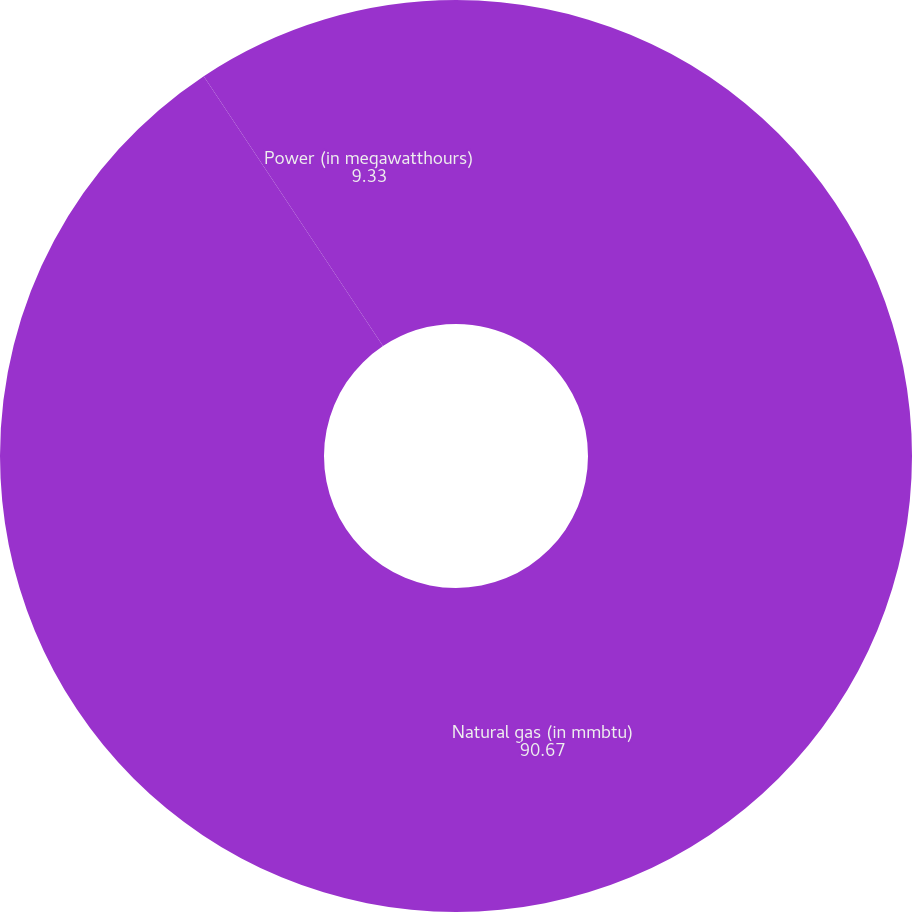Convert chart to OTSL. <chart><loc_0><loc_0><loc_500><loc_500><pie_chart><fcel>Natural gas (in mmbtu)<fcel>Power (in megawatthours)<nl><fcel>90.67%<fcel>9.33%<nl></chart> 